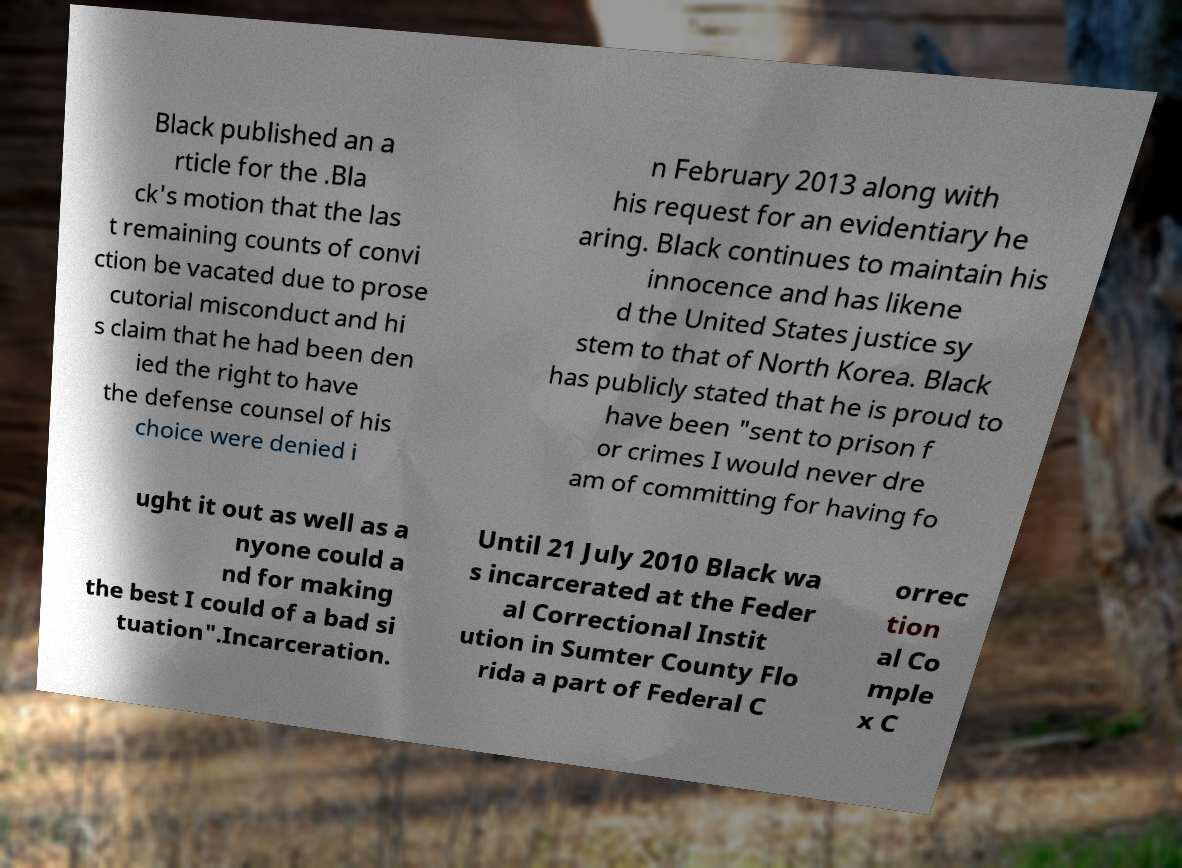What messages or text are displayed in this image? I need them in a readable, typed format. Black published an a rticle for the .Bla ck's motion that the las t remaining counts of convi ction be vacated due to prose cutorial misconduct and hi s claim that he had been den ied the right to have the defense counsel of his choice were denied i n February 2013 along with his request for an evidentiary he aring. Black continues to maintain his innocence and has likene d the United States justice sy stem to that of North Korea. Black has publicly stated that he is proud to have been "sent to prison f or crimes I would never dre am of committing for having fo ught it out as well as a nyone could a nd for making the best I could of a bad si tuation".Incarceration. Until 21 July 2010 Black wa s incarcerated at the Feder al Correctional Instit ution in Sumter County Flo rida a part of Federal C orrec tion al Co mple x C 